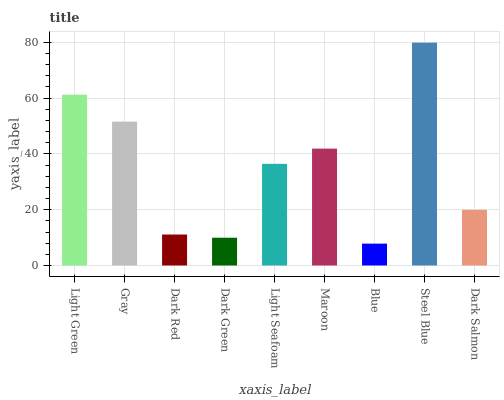Is Blue the minimum?
Answer yes or no. Yes. Is Steel Blue the maximum?
Answer yes or no. Yes. Is Gray the minimum?
Answer yes or no. No. Is Gray the maximum?
Answer yes or no. No. Is Light Green greater than Gray?
Answer yes or no. Yes. Is Gray less than Light Green?
Answer yes or no. Yes. Is Gray greater than Light Green?
Answer yes or no. No. Is Light Green less than Gray?
Answer yes or no. No. Is Light Seafoam the high median?
Answer yes or no. Yes. Is Light Seafoam the low median?
Answer yes or no. Yes. Is Dark Salmon the high median?
Answer yes or no. No. Is Dark Salmon the low median?
Answer yes or no. No. 